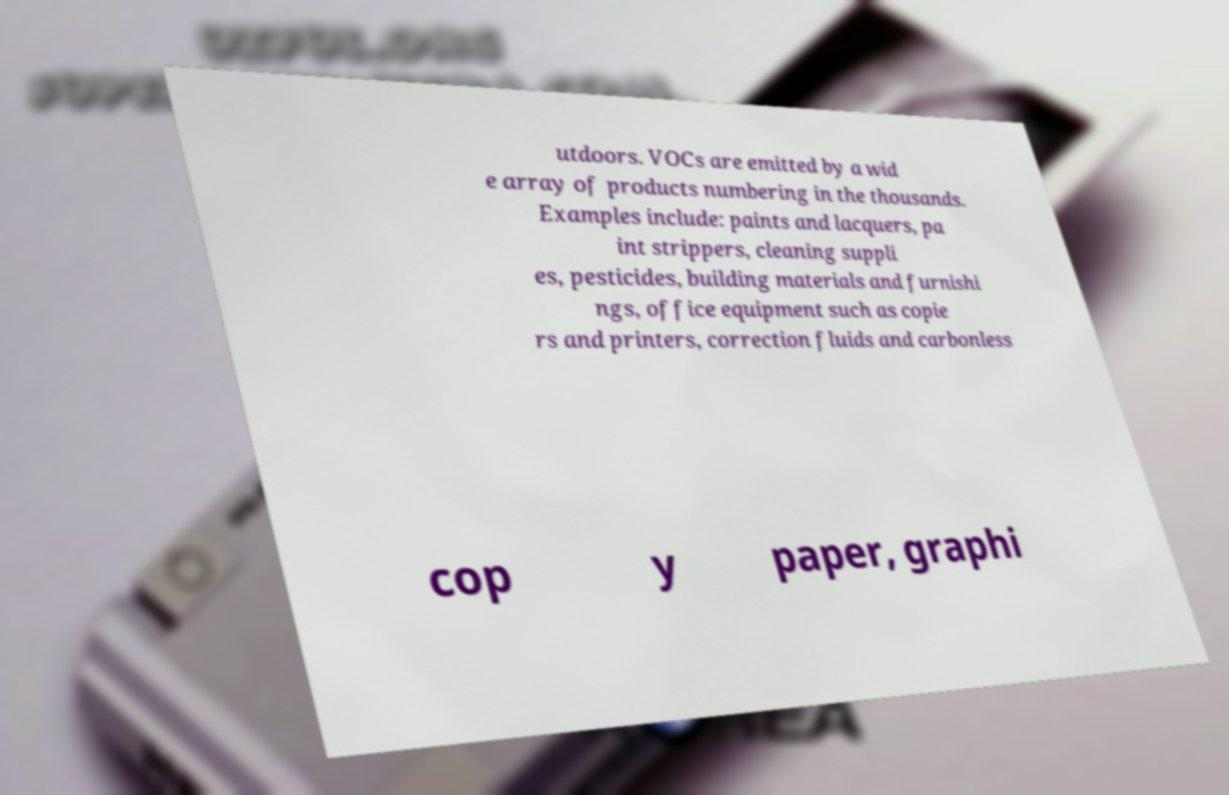Can you read and provide the text displayed in the image?This photo seems to have some interesting text. Can you extract and type it out for me? utdoors. VOCs are emitted by a wid e array of products numbering in the thousands. Examples include: paints and lacquers, pa int strippers, cleaning suppli es, pesticides, building materials and furnishi ngs, office equipment such as copie rs and printers, correction fluids and carbonless cop y paper, graphi 